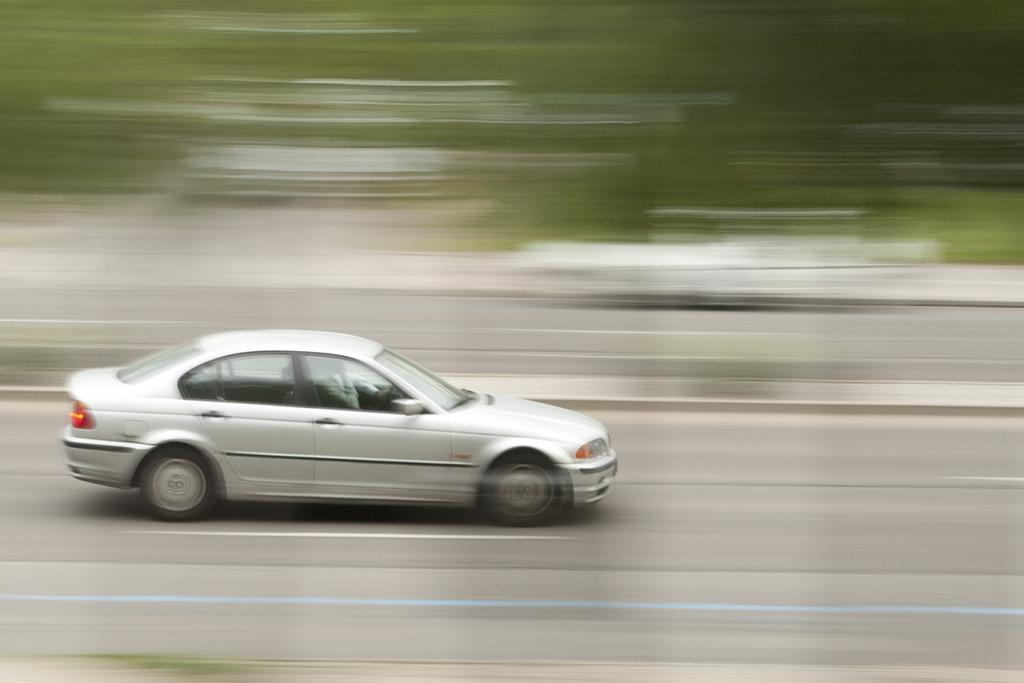What color is the car in the image? The car in the image is silver. What is the car doing in the image? The car is moving on the road. Can you describe the background of the image? The background of the image is blurred. Can you hear the maid talking in the background of the image? There is no mention of a maid or any sound in the image, so it is not possible to answer that question. 